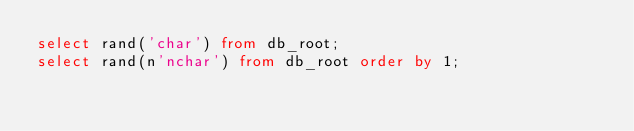<code> <loc_0><loc_0><loc_500><loc_500><_SQL_>select rand('char') from db_root;
select rand(n'nchar') from db_root order by 1;</code> 